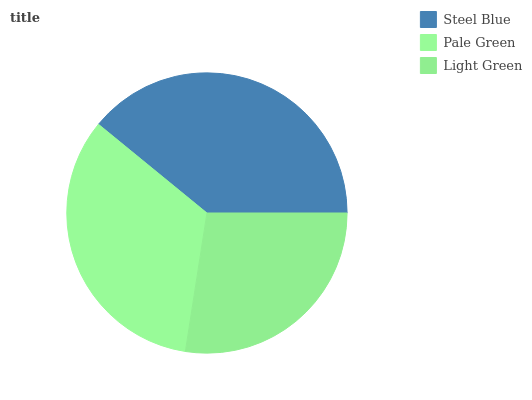Is Light Green the minimum?
Answer yes or no. Yes. Is Steel Blue the maximum?
Answer yes or no. Yes. Is Pale Green the minimum?
Answer yes or no. No. Is Pale Green the maximum?
Answer yes or no. No. Is Steel Blue greater than Pale Green?
Answer yes or no. Yes. Is Pale Green less than Steel Blue?
Answer yes or no. Yes. Is Pale Green greater than Steel Blue?
Answer yes or no. No. Is Steel Blue less than Pale Green?
Answer yes or no. No. Is Pale Green the high median?
Answer yes or no. Yes. Is Pale Green the low median?
Answer yes or no. Yes. Is Light Green the high median?
Answer yes or no. No. Is Light Green the low median?
Answer yes or no. No. 